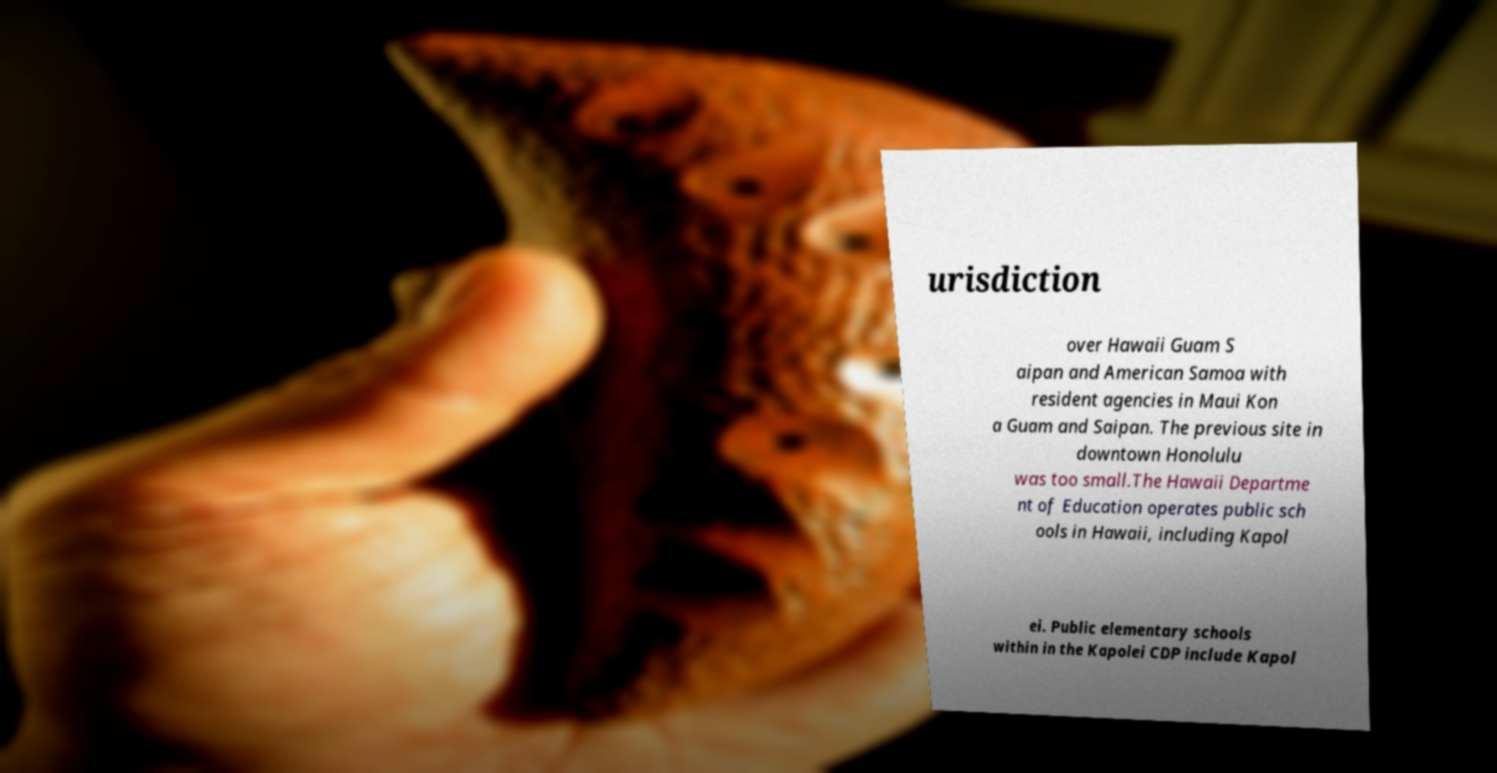What messages or text are displayed in this image? I need them in a readable, typed format. urisdiction over Hawaii Guam S aipan and American Samoa with resident agencies in Maui Kon a Guam and Saipan. The previous site in downtown Honolulu was too small.The Hawaii Departme nt of Education operates public sch ools in Hawaii, including Kapol ei. Public elementary schools within in the Kapolei CDP include Kapol 